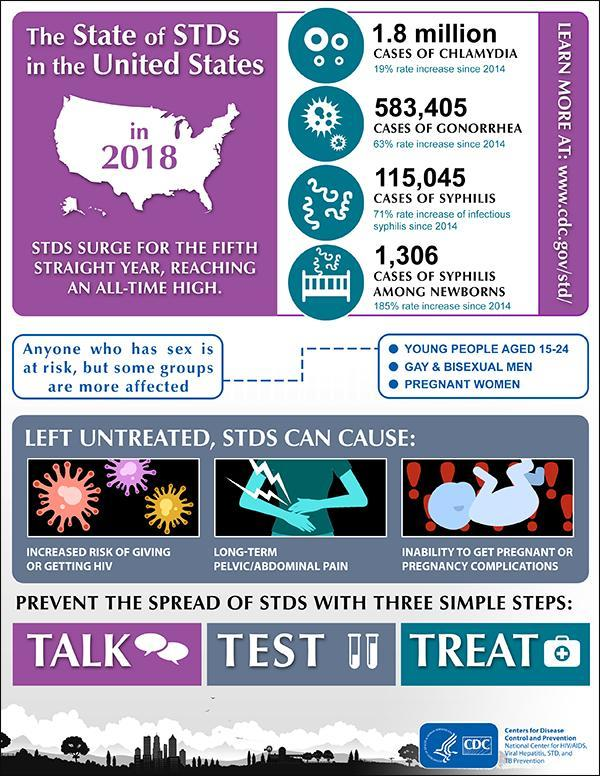Which is the first step that curbs the outbreak of sexually transmitted diseases?
Answer the question with a short phrase. Talk Which is the second step that helps curb sexually transmitted diseases? TEST What is the third step that helps in controlling STDs ? Treat 